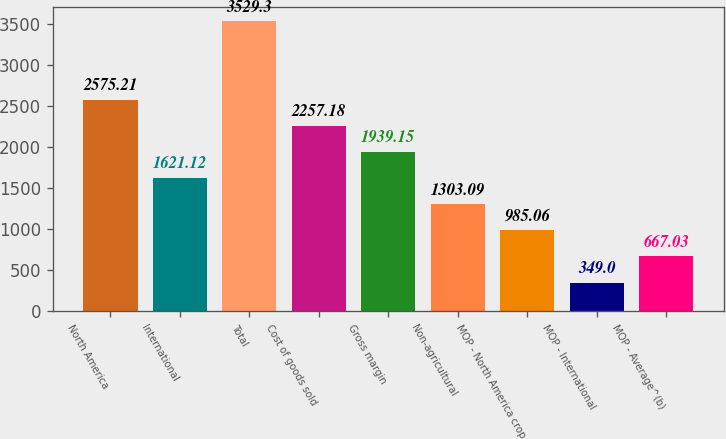Convert chart to OTSL. <chart><loc_0><loc_0><loc_500><loc_500><bar_chart><fcel>North America<fcel>International<fcel>Total<fcel>Cost of goods sold<fcel>Gross margin<fcel>Non-agricultural<fcel>MOP - North America crop<fcel>MOP - International<fcel>MOP - Average^(b)<nl><fcel>2575.21<fcel>1621.12<fcel>3529.3<fcel>2257.18<fcel>1939.15<fcel>1303.09<fcel>985.06<fcel>349<fcel>667.03<nl></chart> 